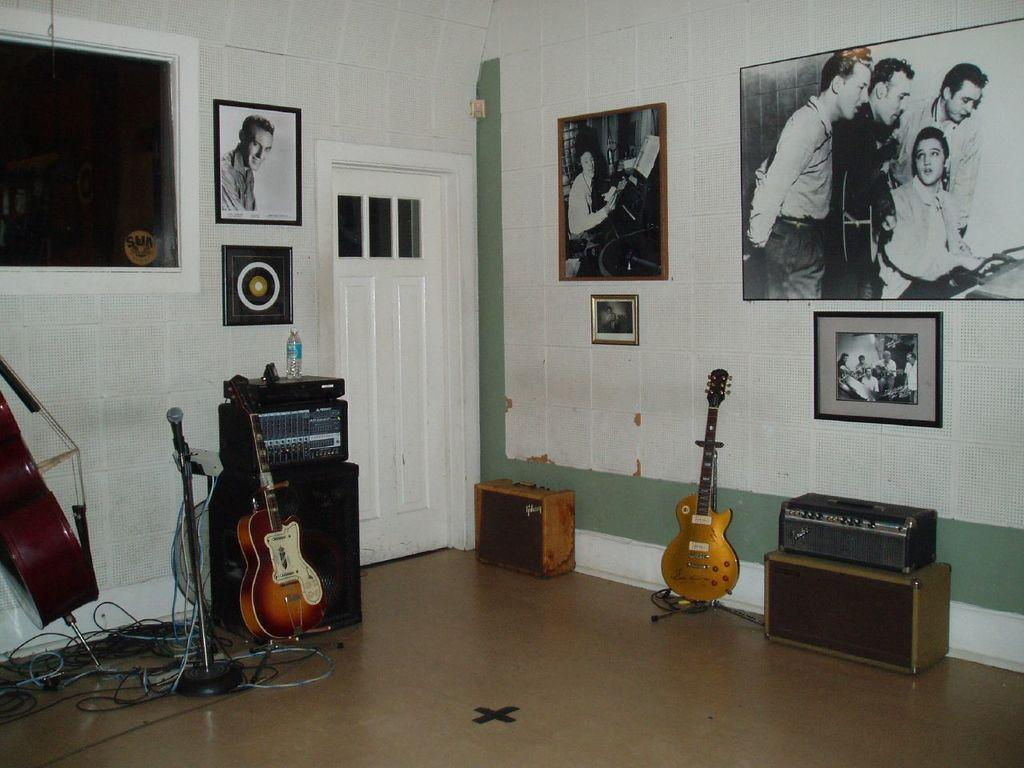What type of space is depicted in the image? The image shows a room. What can be found in the room? The room contains musical instruments, including guitars and microphones. Are there any decorative elements in the room? Yes, there are photo frames present on the walls. How can one enter or exit the room? There is a door in the middle of the room. Where is the sink located in the image? There is no sink present in the image. Can you see a kite being flown in the room? No, there is no kite visible in the image. 